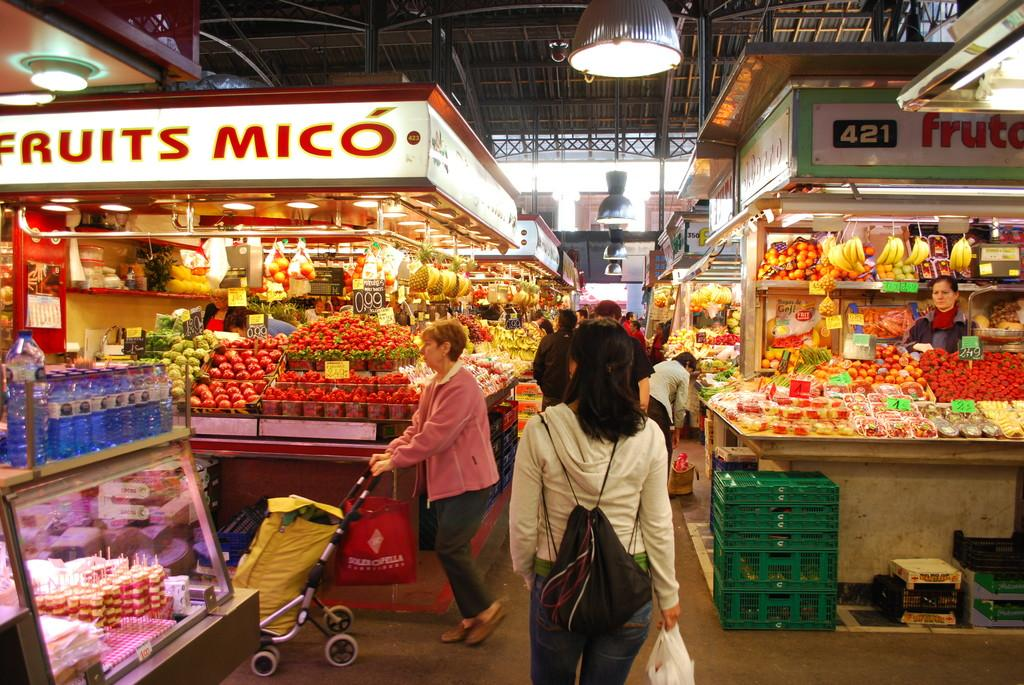<image>
Present a compact description of the photo's key features. People shop in a store, with a section labelled Fruits Mico. 